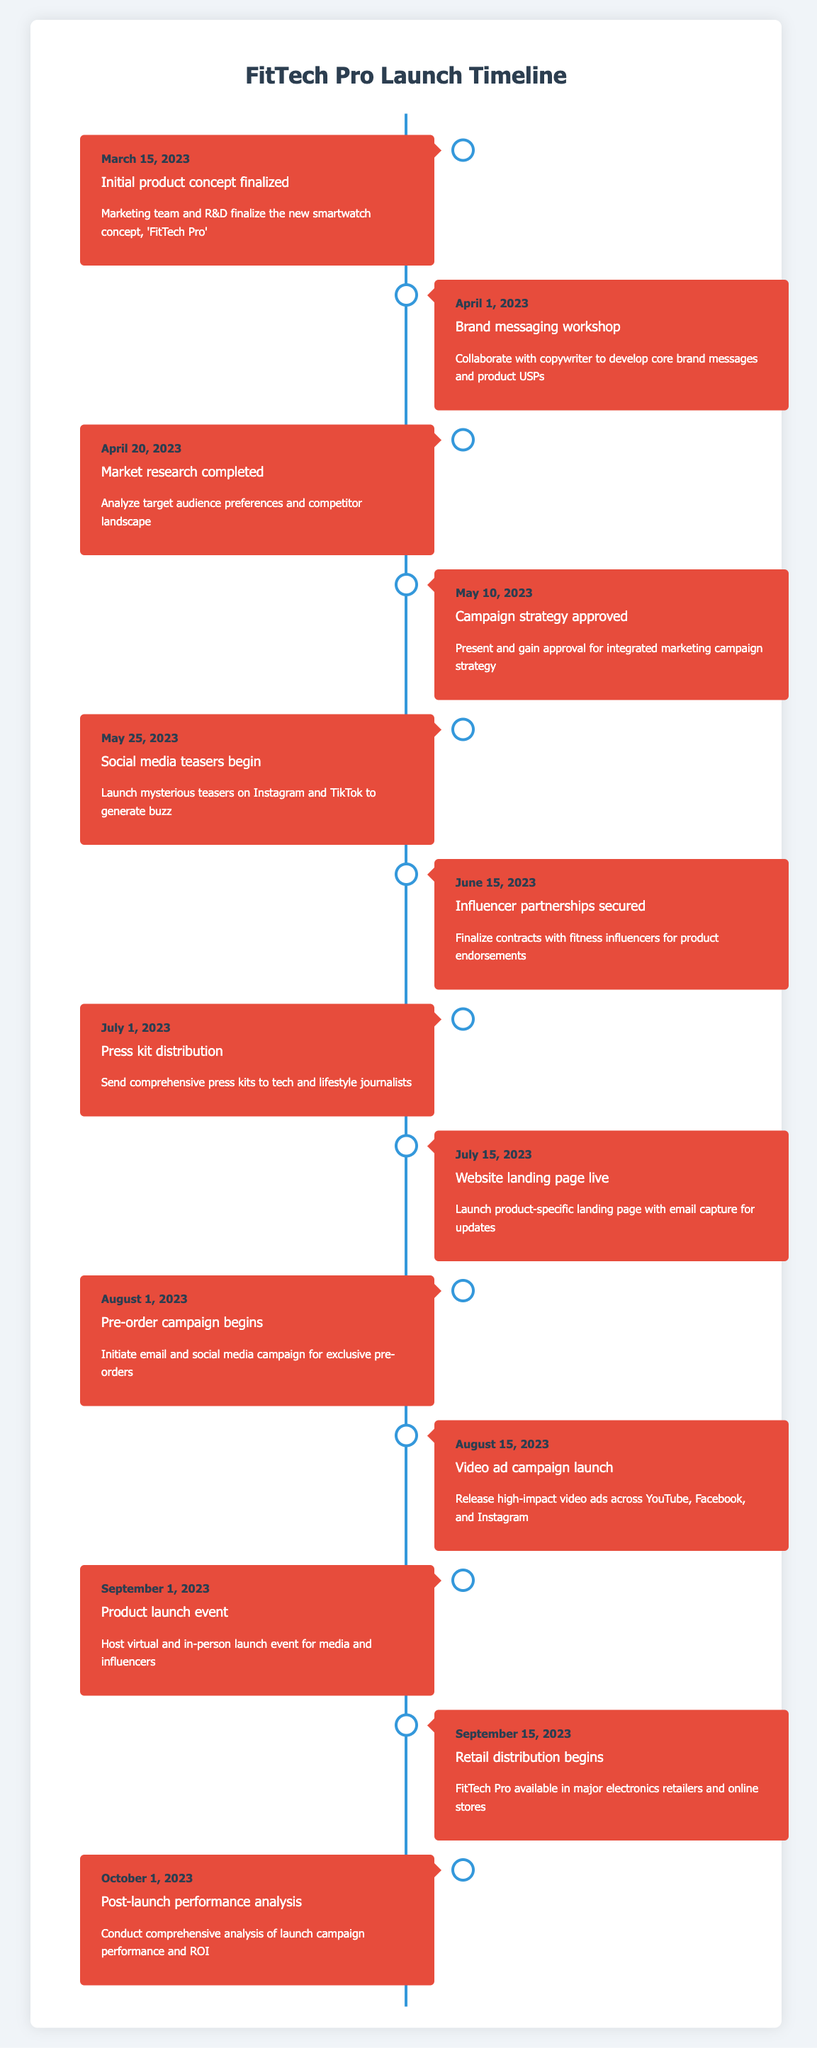What was the date of the initial product concept finalization? The table lists the milestone "Initial product concept finalized" along with its date, which is "March 15, 2023."
Answer: March 15, 2023 How many days are there between the brand messaging workshop and the campaign strategy approval? The brand messaging workshop took place on April 1, 2023, and the campaign strategy was approved on May 10, 2023. The number of days between these two dates is 39 days.
Answer: 39 days Did influencer partnerships get secured before the social media teasers began? The timeline indicates that influencer partnerships were secured on June 15, 2023, while social media teasers began on May 25, 2023. Since June 15 is after May 25, the statement is false.
Answer: No What milestone occurred immediately before the pre-order campaign began? The pre-order campaign began on August 1, 2023, and looking at the timeline, the milestone immediately preceding it is the "Website landing page live" on July 15, 2023.
Answer: Website landing page live Which two milestones occurred in the month of July? In the table, the milestones for July are "Press kit distribution" on July 1, 2023, and "Website landing page live" on July 15, 2023. Thus, these two milestones occurred in the month of July.
Answer: Press kit distribution and Website landing page live How many milestones were there between the product launch event and the post-launch performance analysis? The product launch event occurred on September 1, 2023, and the post-launch performance analysis was on October 1, 2023. There are two milestones in between these two dates: "Retail distribution begins" on September 15, 2023. Thus, 1 milestone is present between them.
Answer: 1 milestone Were there more initiatives focused on pre-launch activities than post-launch activities? The pre-launch activities included milestones such as social media teasers, influencer partnerships, press kit distribution, and the product launch event—all occurring before September 1, 2023. After the launch, there is only the post-launch performance analysis milestone. So, there are more pre-launch initiatives than post-launch ones.
Answer: Yes What is the total number of milestones listed in this timeline? By counting each row in the timeline, there are 13 milestones from "Initial product concept finalized" to "Post-launch performance analysis," giving a total count of 13 milestones.
Answer: 13 milestones Which milestone relates to securing endorsements and when did it occur? The milestone about securing endorsements is "Influencer partnerships secured," which took place on June 15, 2023, as specified in the timeline.
Answer: Influencer partnerships secured, June 15, 2023 